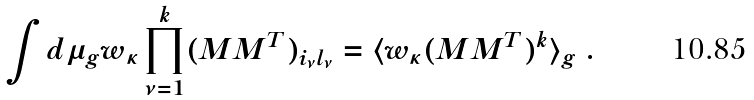Convert formula to latex. <formula><loc_0><loc_0><loc_500><loc_500>\int d \mu _ { g } w _ { \kappa } \prod _ { \nu = 1 } ^ { k } ( M M ^ { T } ) _ { i _ { \nu } l _ { \nu } } = \langle w _ { \kappa } ( M M ^ { T } ) ^ { k } \rangle _ { g } \ .</formula> 